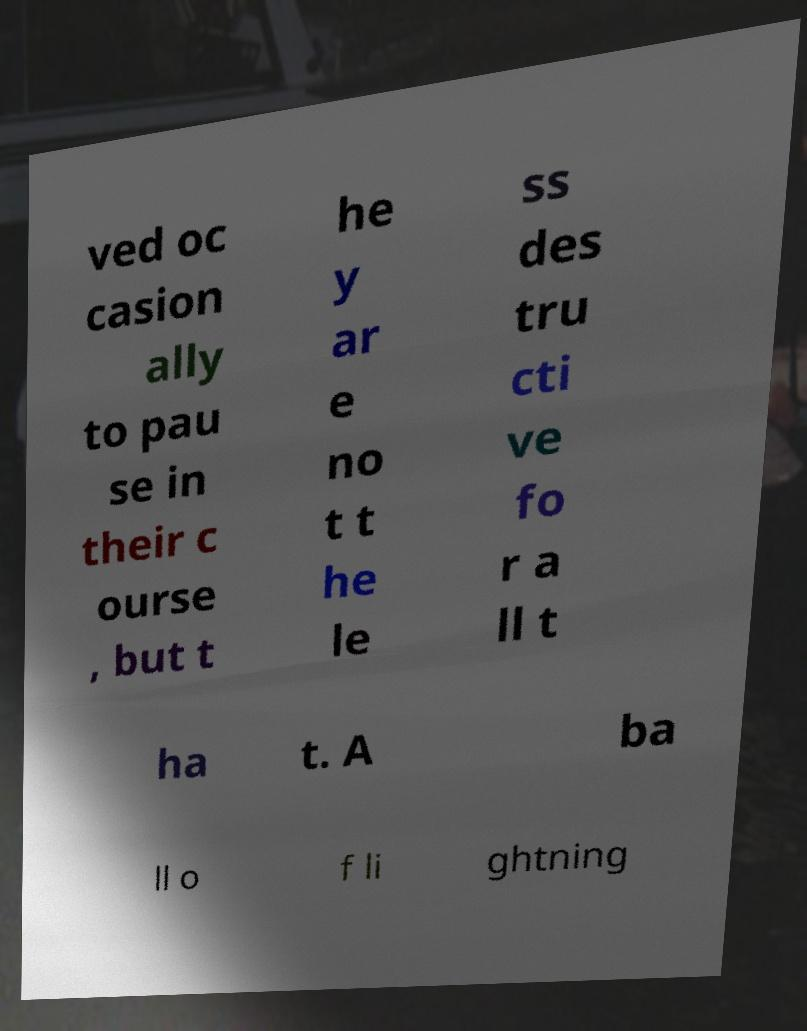There's text embedded in this image that I need extracted. Can you transcribe it verbatim? ved oc casion ally to pau se in their c ourse , but t he y ar e no t t he le ss des tru cti ve fo r a ll t ha t. A ba ll o f li ghtning 